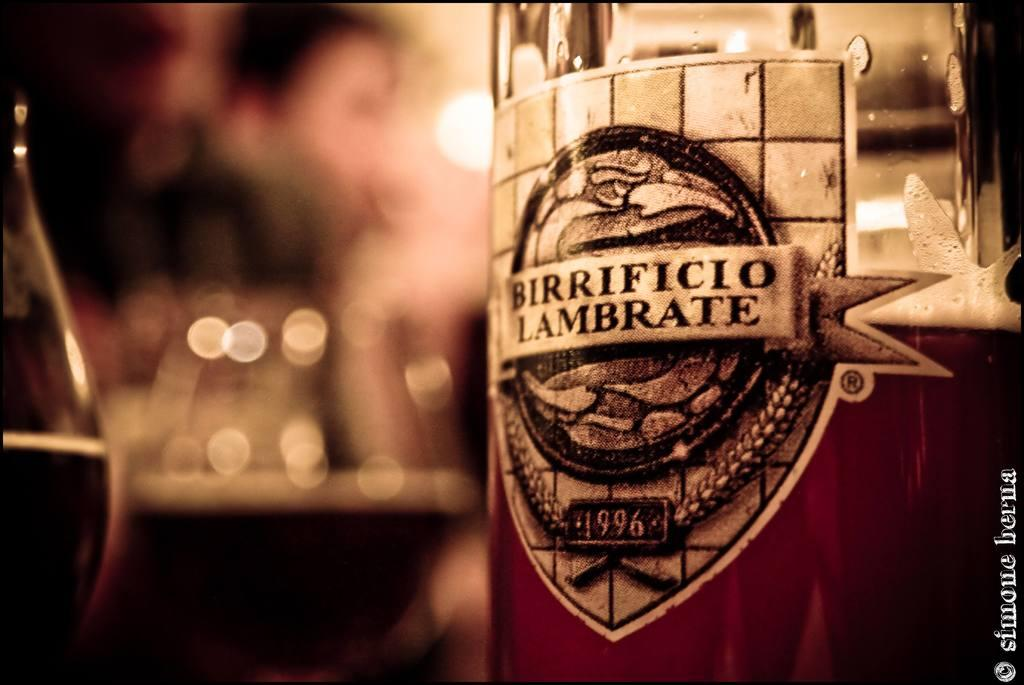Provide a one-sentence caption for the provided image. A close up of the label on a bottle of Birrificio Lambrate 1996. 